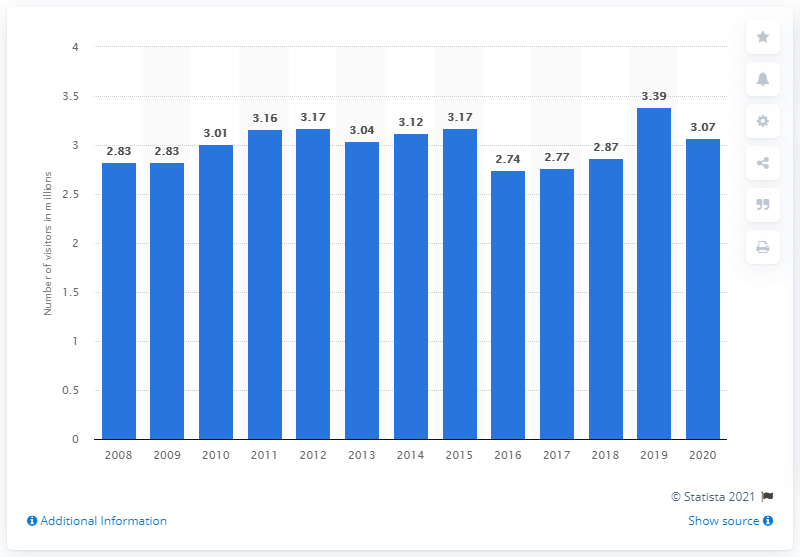How many people visited the Chattahoochee River National Recreation Area in 2020? In 2020, the Chattahoochee River National Recreation Area welcomed approximately 3.07 million visitors, according to the data visualized in the provided chart. 